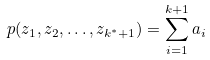<formula> <loc_0><loc_0><loc_500><loc_500>p ( z _ { 1 } , z _ { 2 } , \dots , z _ { k ^ { \ast } + 1 } ) = \sum _ { i = 1 } ^ { k + 1 } a _ { i }</formula> 